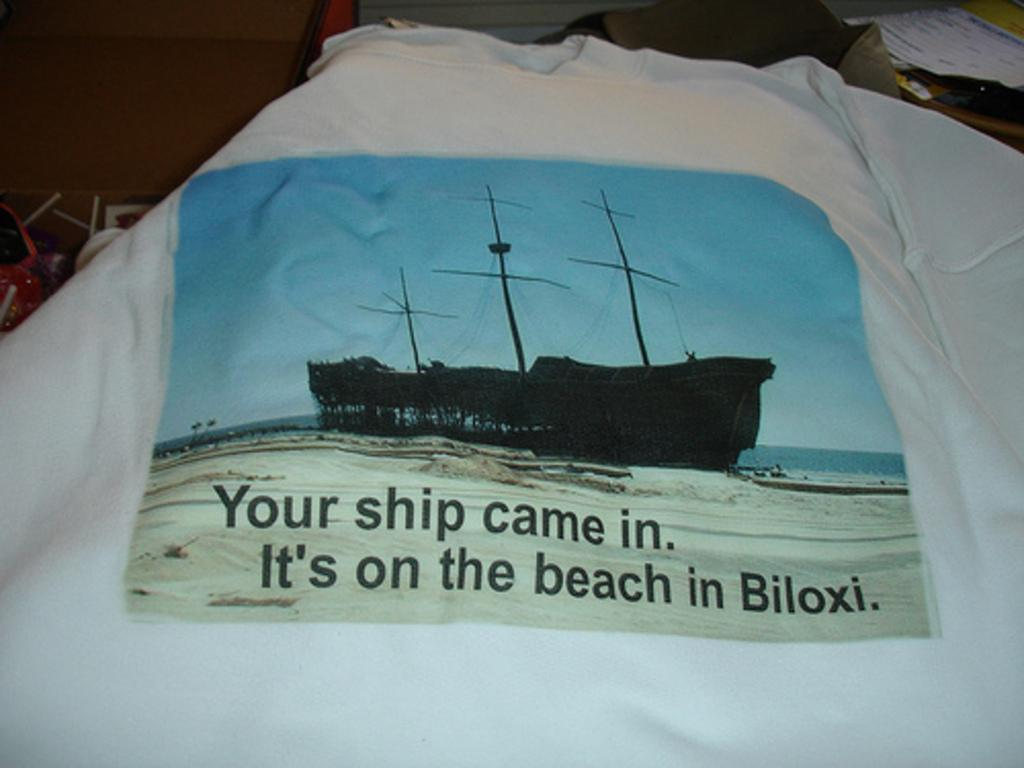What is featured on the T-shirt in the image? There is a print on a T-shirt in the image. What type of wood can be seen in the image? There is no wood present in the image; it features a print on a T-shirt. How many clouds are visible in the image? There are no clouds visible in the image; it features a print on a T-shirt. 